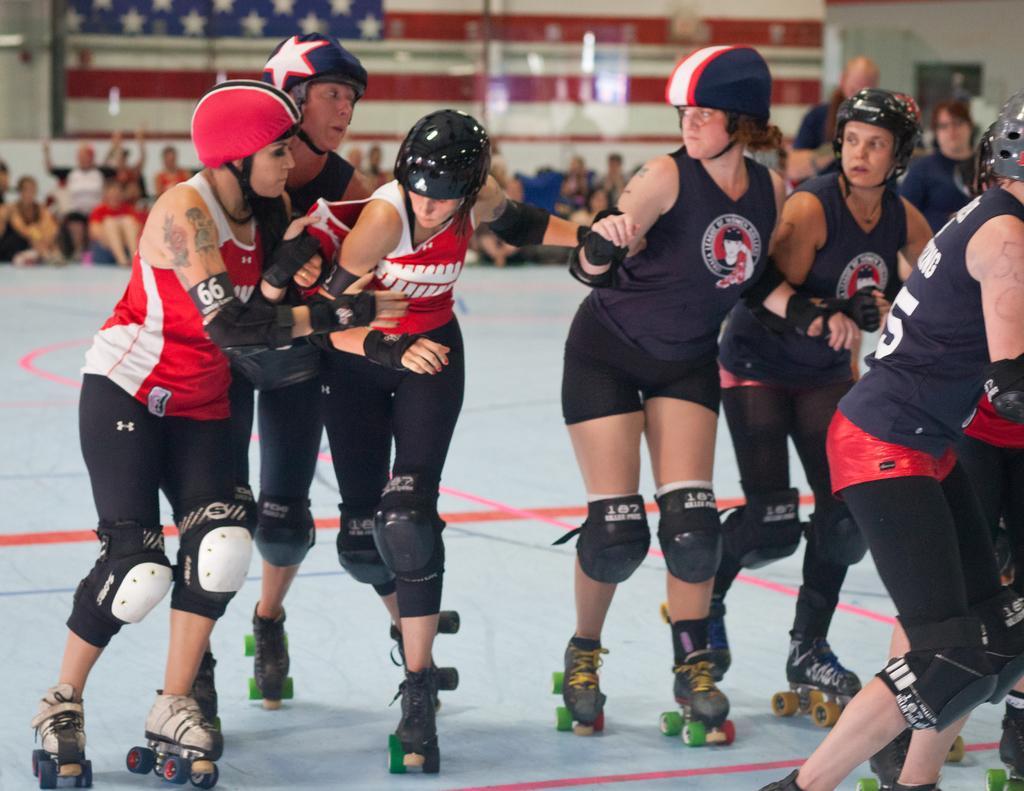Please provide a concise description of this image. In the foreground of the picture there are women skating, they are wearing helmets. In the background there are audience. At the top there is a flag. On the right there is a door. The background is blurred. 